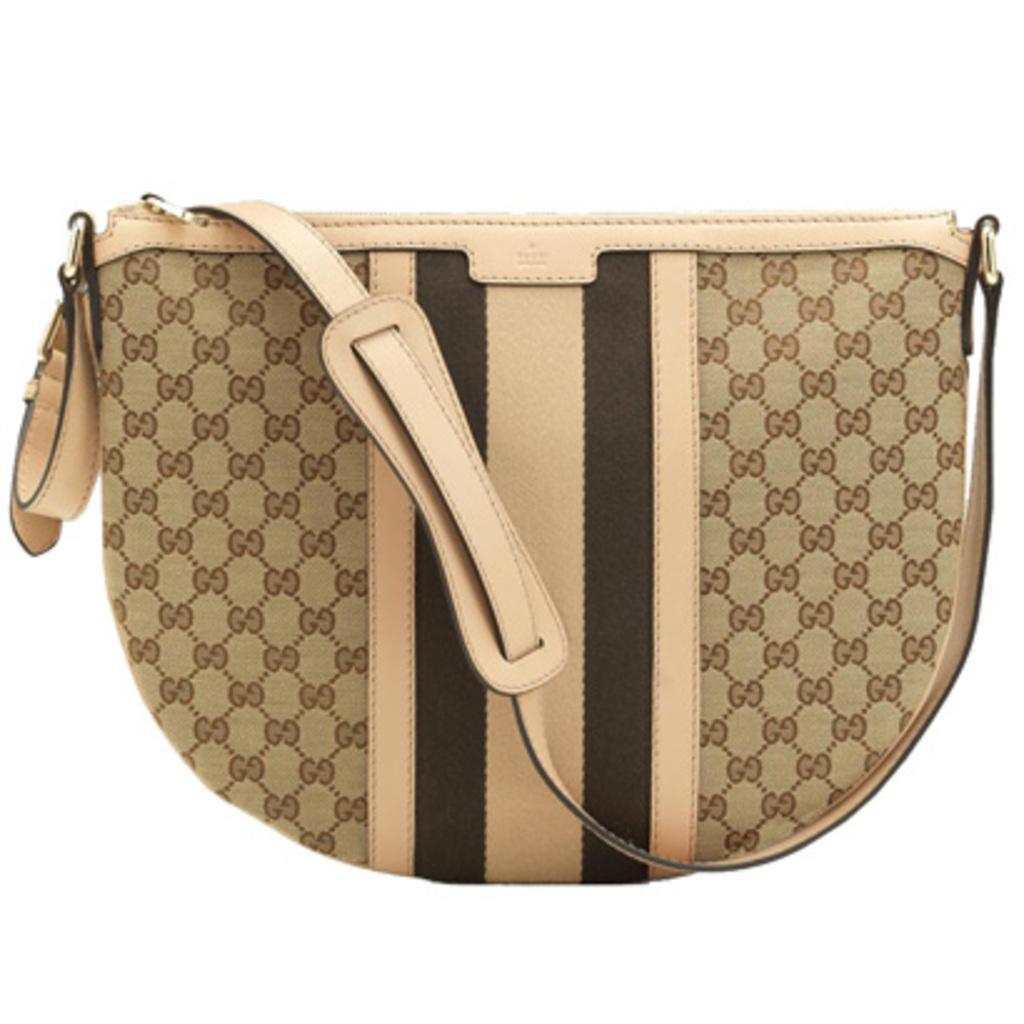Could you give a brief overview of what you see in this image? In this image, we can see women handbag. And it is leather piece. And hanging we can see zip and ring. 